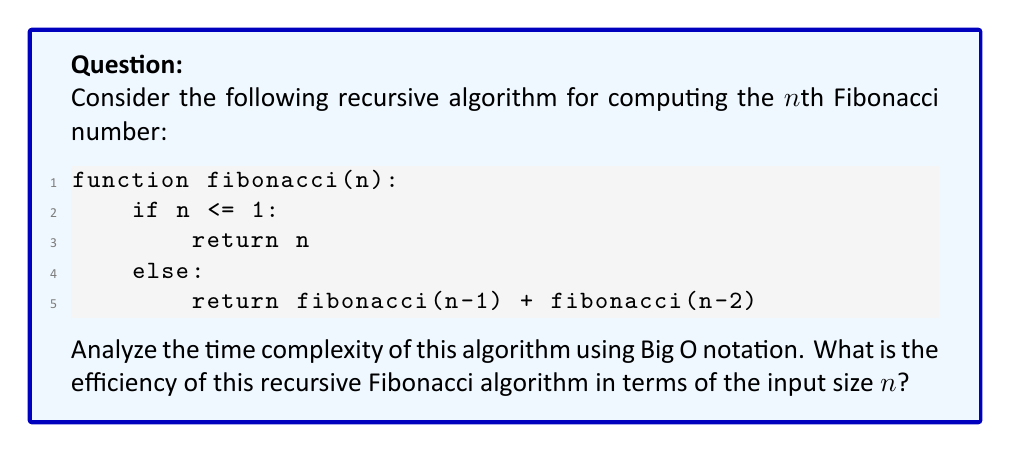Could you help me with this problem? Let's analyze the time complexity of this recursive Fibonacci algorithm step by step:

1) First, we need to understand the recurrence relation:
   $T(n) = T(n-1) + T(n-2) + O(1)$, where $T(n)$ is the time taken for input n.

2) This recurrence relation forms a binary tree of function calls:
   - Each node splits into two child nodes
   - The depth of the tree is n

3) To visualize this, let's look at the call tree for $n=5$:

   [asy]
   unitsize(30);
   void drawNode(pair p, string s) {
     fill(p, circle(0.3), white);
     draw(p, circle(0.3));
     label(s, p);
   }
   void connect(pair a, pair b) {
     draw(a--b);
   }
   drawNode((0,0), "F(5)");
   drawNode((-1,-1), "F(4)");
   drawNode((1,-1), "F(3)");
   drawNode((-1.5,-2), "F(3)");
   drawNode((-0.5,-2), "F(2)");
   drawNode((0.5,-2), "F(2)");
   drawNode((1.5,-2), "F(1)");
   connect((0,0), (-1,-1));
   connect((0,0), (1,-1));
   connect((-1,-1), (-1.5,-2));
   connect((-1,-1), (-0.5,-2));
   connect((1,-1), (0.5,-2));
   connect((1,-1), (1.5,-2));
   label("...", (-1.5,-2.5));
   label("...", (-0.5,-2.5));
   label("...", (0.5,-2.5));
   [/asy]

4) We can see that the number of function calls roughly doubles at each level.

5) The number of nodes in this tree is approximately $2^n$.

6) Each function call does a constant amount of work (addition and comparison).

7) Therefore, the total time complexity is proportional to the number of nodes in the tree.

8) This gives us a time complexity of $O(2^n)$.

9) More precisely, the exact number of function calls is given by the formula:
   $F_{n+1} - 1$, where $F_n$ is the nth Fibonacci number.

10) However, for Big O notation, we simplify this to $O(2^n)$ as $F_n$ grows exponentially, but slightly slower than $2^n$.
Answer: $O(2^n)$ 